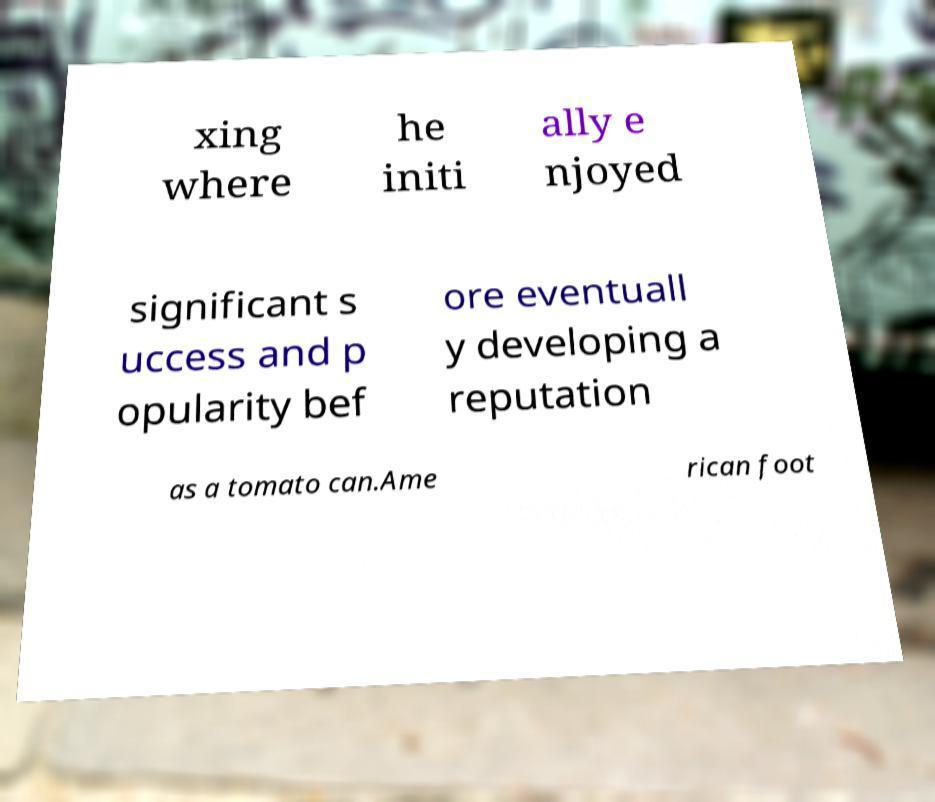What messages or text are displayed in this image? I need them in a readable, typed format. xing where he initi ally e njoyed significant s uccess and p opularity bef ore eventuall y developing a reputation as a tomato can.Ame rican foot 